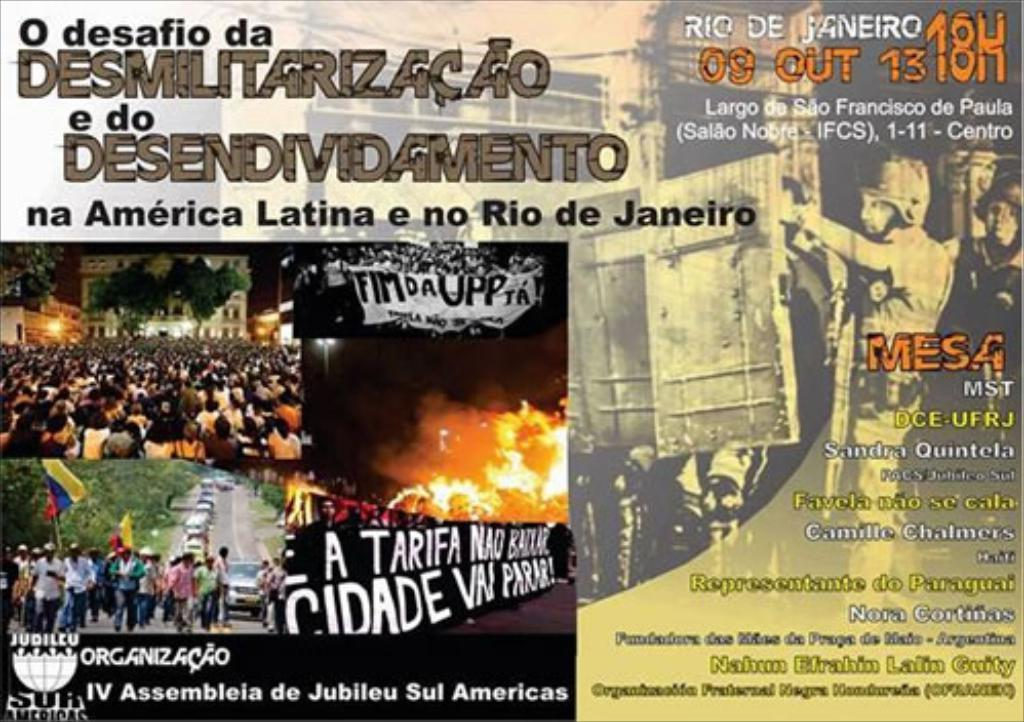<image>
Provide a brief description of the given image. a poster for some event in rio de janeiro has many pictures on it 